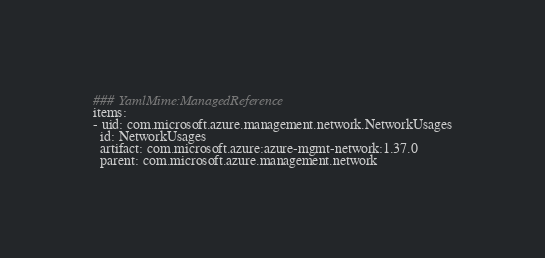<code> <loc_0><loc_0><loc_500><loc_500><_YAML_>### YamlMime:ManagedReference
items:
- uid: com.microsoft.azure.management.network.NetworkUsages
  id: NetworkUsages
  artifact: com.microsoft.azure:azure-mgmt-network:1.37.0
  parent: com.microsoft.azure.management.network</code> 